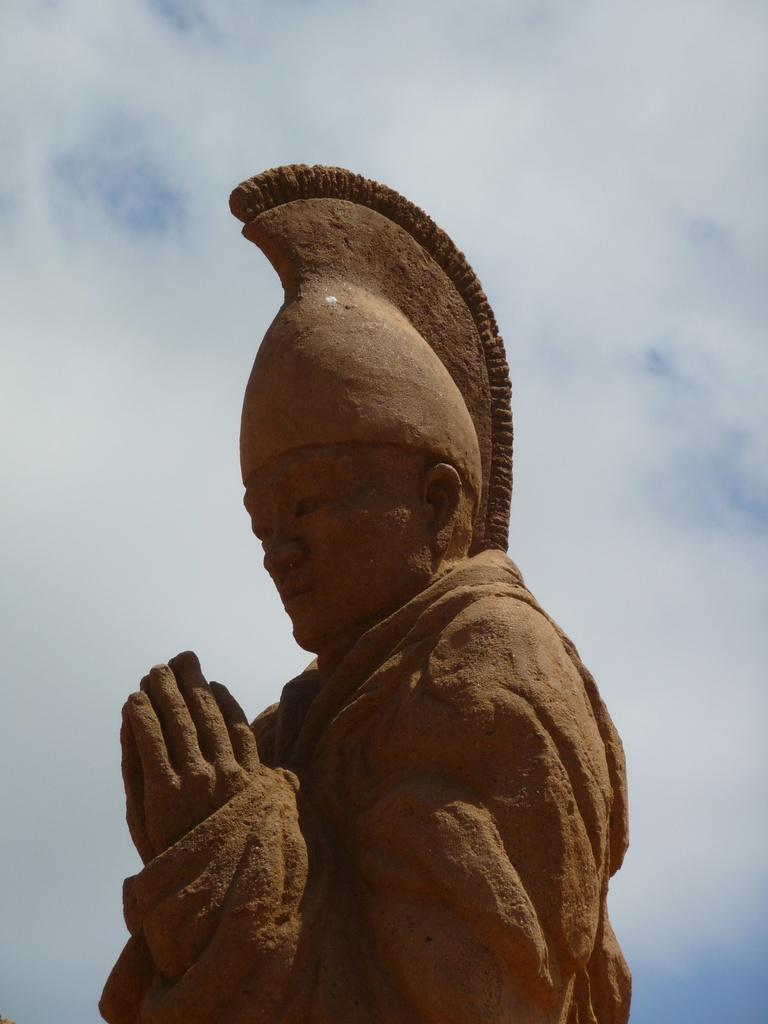What is the main subject of the image? There is a sculpture of a man in the image. What can be seen in the background of the image? The sky is visible in the image. What type of beast can be seen in the room in the image? There is no beast or room present in the image; it features a sculpture of a man and the sky. What is the condition of the man's ear in the image? The image is of a sculpture, and sculptures do not have ears or any other physical features that can be in a condition. 